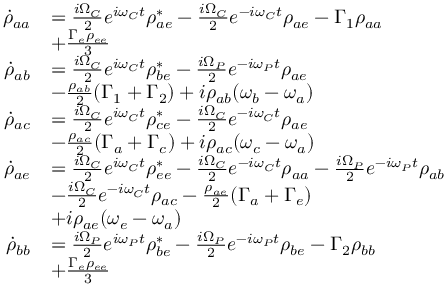Convert formula to latex. <formula><loc_0><loc_0><loc_500><loc_500>\begin{array} { r l } { \dot { \rho } _ { a a } } & { = \frac { i \Omega _ { C } } { 2 } e ^ { i \omega _ { C } t } \rho _ { a e } ^ { * } - \frac { i \Omega _ { C } } { 2 } e ^ { - i \omega _ { C } t } \rho _ { a e } - \Gamma _ { 1 } \rho _ { a a } } \\ & { + \frac { \Gamma _ { e } \rho _ { e e } } { 3 } } \\ { \dot { \rho } _ { a b } } & { = \frac { i \Omega _ { C } } { 2 } e ^ { i \omega _ { C } t } \rho _ { b e } ^ { * } - \frac { i \Omega _ { P } } { 2 } e ^ { - i \omega _ { P } t } \rho _ { a e } } \\ & { - \frac { \rho _ { a b } } { 2 } ( \Gamma _ { 1 } + \Gamma _ { 2 } ) + i \rho _ { a b } ( \omega _ { b } - \omega _ { a } ) } \\ { \dot { \rho } _ { a c } } & { = \frac { i \Omega _ { C } } { 2 } e ^ { i \omega _ { C } t } \rho _ { c e } ^ { * } - \frac { i \Omega _ { C } } { 2 } e ^ { - i \omega _ { C } t } \rho _ { a e } } \\ & { - \frac { \rho _ { a c } } { 2 } ( \Gamma _ { a } + \Gamma _ { c } ) + i \rho _ { a c } ( \omega _ { c } - \omega _ { a } ) } \\ { \dot { \rho } _ { a e } } & { = \frac { i \Omega _ { C } } { 2 } e ^ { i \omega _ { C } t } \rho _ { e e } ^ { * } - \frac { i \Omega _ { C } } { 2 } e ^ { - i \omega _ { C } t } \rho _ { a a } - \frac { i \Omega _ { P } } { 2 } e ^ { - i \omega _ { P } t } \rho _ { a b } } \\ & { - \frac { i \Omega _ { C } } { 2 } e ^ { - i \omega _ { C } t } \rho _ { a c } - \frac { \rho _ { a e } } { 2 } ( \Gamma _ { a } + \Gamma _ { e } ) } \\ & { + i \rho _ { a e } ( \omega _ { e } - \omega _ { a } ) } \\ { \dot { \rho } _ { b b } } & { = \frac { i \Omega _ { P } } { 2 } e ^ { i \omega _ { P } t } \rho _ { b e } ^ { * } - \frac { i \Omega _ { P } } { 2 } e ^ { - i \omega _ { P } t } \rho _ { b e } - \Gamma _ { 2 } \rho _ { b b } } \\ & { + \frac { \Gamma _ { e } \rho _ { e e } } { 3 } } \end{array}</formula> 